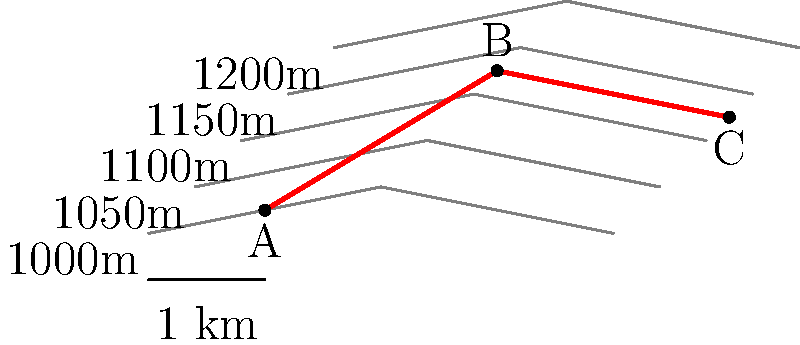You're planning a stargazing hike along the trail marked in red on the topographic map. What is the approximate elevation gain between points A and B? To determine the elevation gain between points A and B, we need to follow these steps:

1. Identify the contour interval: The elevation difference between each contour line is 50m (1050m - 1000m = 50m).

2. Locate point A: It's between the 1000m and 1050m contour lines, closer to the 1000m line. We can estimate its elevation as approximately 1010m.

3. Locate point B: It's between the 1150m and 1200m contour lines, closer to the 1150m line. We can estimate its elevation as approximately 1160m.

4. Calculate the elevation difference:
   $\text{Elevation gain} = \text{Elevation at B} - \text{Elevation at A}$
   $\text{Elevation gain} = 1160\text{m} - 1010\text{m} = 150\text{m}$

Therefore, the approximate elevation gain between points A and B is 150 meters.
Answer: 150 meters 